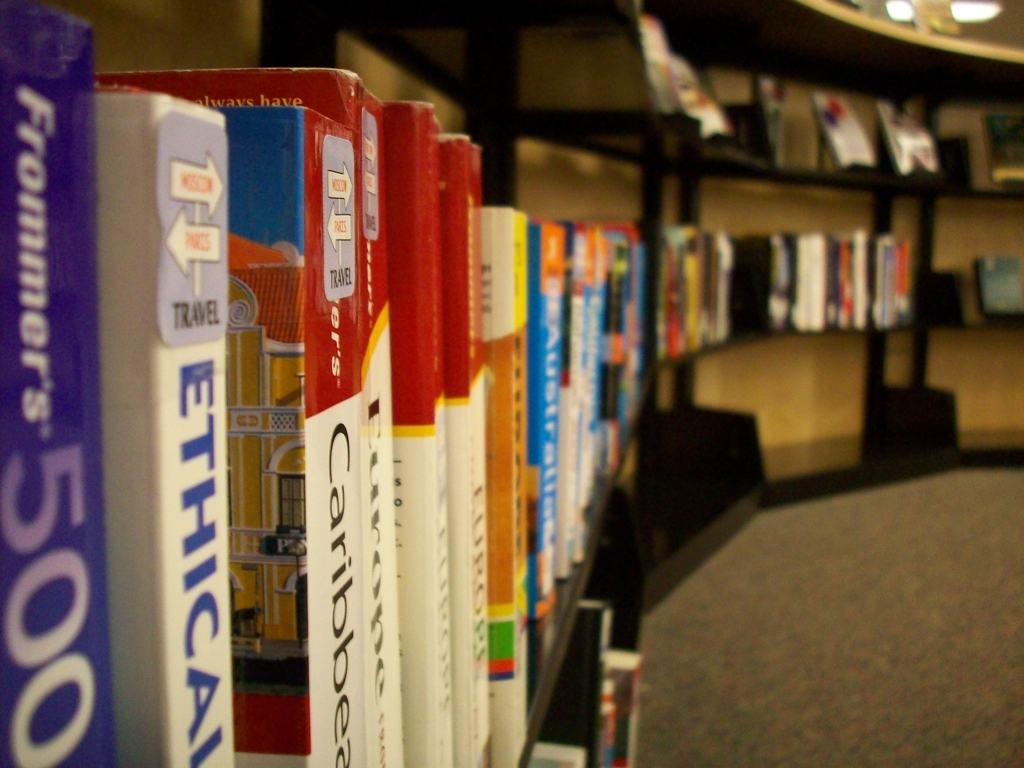What genres of books are present in this image? The image primarily features travel guides, as indicated by the visible titles and the 'TRAVEL' label on the shelf. These books seem to cater to global adventurers, offering insights and itineraries for destinations such as the Caribbean and other locales. 